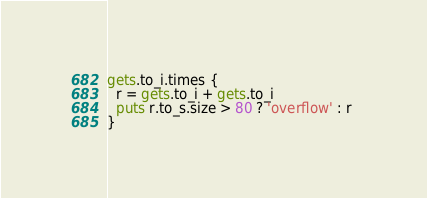<code> <loc_0><loc_0><loc_500><loc_500><_Ruby_>gets.to_i.times {
  r = gets.to_i + gets.to_i
  puts r.to_s.size > 80 ? 'overflow' : r 
}</code> 